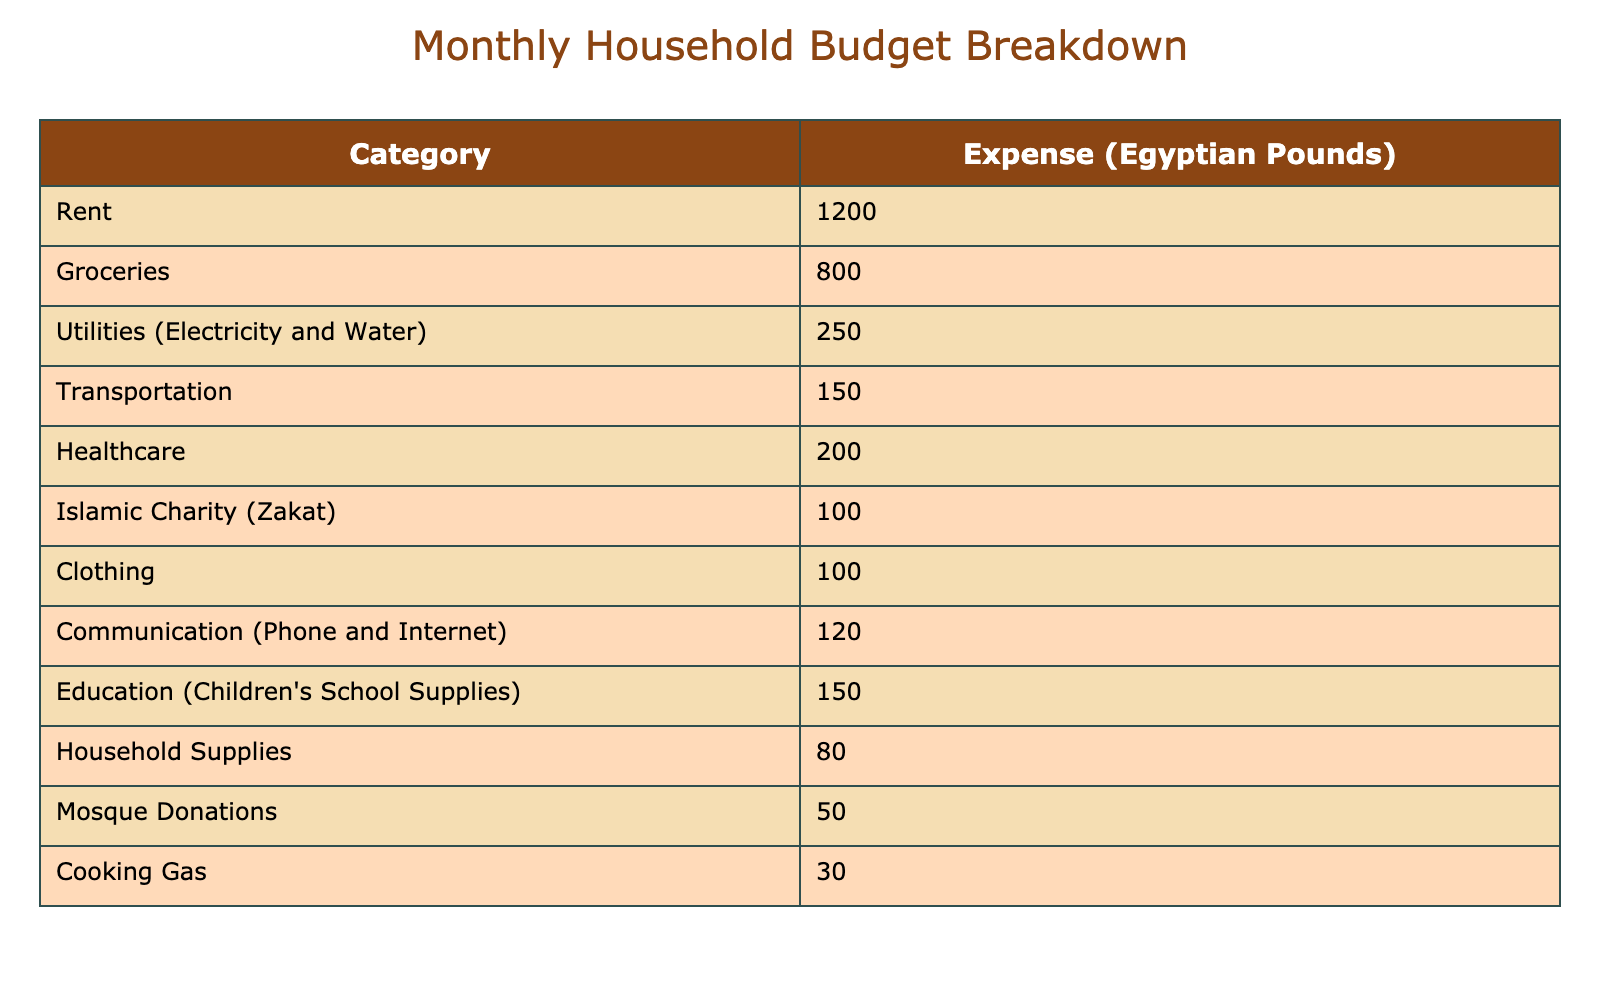What is the total amount spent on groceries and rent? To find the total amount spent on groceries and rent, I need to add the values for these two categories. Groceries cost 800 Egyptian Pounds and rent is 1200 Egyptian Pounds. So, the total is 800 + 1200 = 2000 Egyptian Pounds.
Answer: 2000 Is the expense on transportation higher than the expense on cooking gas? The table shows that transportation costs 150 Egyptian Pounds while cooking gas costs 30 Egyptian Pounds. Since 150 is greater than 30, the answer is yes.
Answer: Yes What is the average monthly expense for healthcare and clothing? To find the average, I first add the expenses for healthcare (200 Egyptian Pounds) and clothing (100 Egyptian Pounds), which totals 200 + 100 = 300 Egyptian Pounds. Then, I divide this sum by 2 to find the average: 300 / 2 = 150 Egyptian Pounds.
Answer: 150 Are household supplies more expensive than mosque donations? Household supplies cost 80 Egyptian Pounds and mosque donations cost 50 Egyptian Pounds. Since 80 is greater than 50, the answer is yes.
Answer: Yes What percentage of the total budget is allocated to Islamic charity (Zakat)? First, I calculate the total budget by adding up all the expenses: 1200 + 800 + 250 + 150 + 200 + 100 + 100 + 120 + 150 + 80 + 50 + 30 = 2080 Egyptian Pounds. Islamic charity (Zakat) costs 100 Egyptian Pounds. To find the percentage, I use the formula (100 / 2080) * 100 = 4.81%.
Answer: Approximately 4.81% What is the total spending on utilities and communication? The expenses for utilities (electricity and water) and communication are 250 Egyptian Pounds and 120 Egyptian Pounds, respectively. Adding these two values gives 250 + 120 = 370 Egyptian Pounds.
Answer: 370 Is the expense on education greater than the sum of the expenses on mosque donations and cooking gas? Education expenses are 150 Egyptian Pounds. The sum of mosque donations (50 Egyptian Pounds) and cooking gas (30 Egyptian Pounds) is 50 + 30 = 80 Egyptian Pounds. Since 150 is greater than 80, the answer is yes.
Answer: Yes What is the total amount spent on all household supplies categories listed in the budget? To calculate the total for household supplies, I add all the specific categories: groceries (800), utilities (250), transportation (150), healthcare (200), clothing (100), communication (120), education (150), household supplies (80), mosque donations (50), and cooking gas (30): 800 + 250 + 150 + 200 + 100 + 120 + 150 + 80 + 50 + 30 = 2080 Egyptian Pounds.
Answer: 2080 